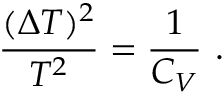Convert formula to latex. <formula><loc_0><loc_0><loc_500><loc_500>\frac { ( \Delta T ) ^ { 2 } } { T ^ { 2 } } = { \frac { 1 } { C _ { V } } } \ .</formula> 